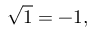<formula> <loc_0><loc_0><loc_500><loc_500>{ \sqrt { 1 } } = - 1 ,</formula> 